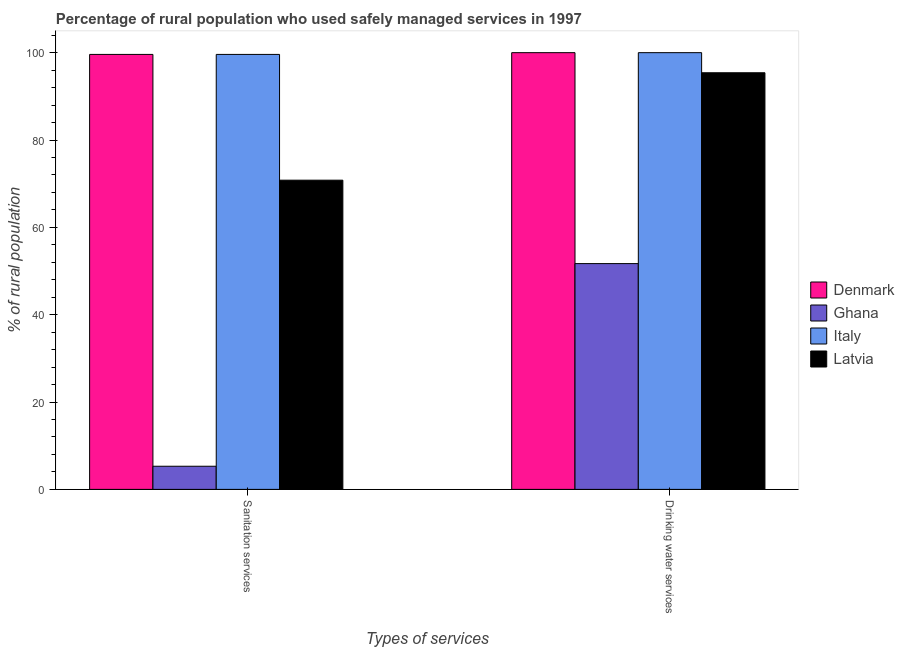How many different coloured bars are there?
Keep it short and to the point. 4. How many bars are there on the 1st tick from the left?
Keep it short and to the point. 4. How many bars are there on the 1st tick from the right?
Make the answer very short. 4. What is the label of the 2nd group of bars from the left?
Offer a very short reply. Drinking water services. What is the percentage of rural population who used sanitation services in Latvia?
Your response must be concise. 70.8. Across all countries, what is the maximum percentage of rural population who used sanitation services?
Your answer should be very brief. 99.6. Across all countries, what is the minimum percentage of rural population who used drinking water services?
Offer a very short reply. 51.7. In which country was the percentage of rural population who used sanitation services maximum?
Offer a very short reply. Denmark. What is the total percentage of rural population who used sanitation services in the graph?
Make the answer very short. 275.3. What is the difference between the percentage of rural population who used sanitation services in Denmark and that in Latvia?
Your answer should be very brief. 28.8. What is the difference between the percentage of rural population who used sanitation services in Italy and the percentage of rural population who used drinking water services in Ghana?
Keep it short and to the point. 47.9. What is the average percentage of rural population who used drinking water services per country?
Offer a terse response. 86.78. What is the difference between the percentage of rural population who used sanitation services and percentage of rural population who used drinking water services in Denmark?
Give a very brief answer. -0.4. In how many countries, is the percentage of rural population who used drinking water services greater than 84 %?
Offer a very short reply. 3. What is the ratio of the percentage of rural population who used sanitation services in Ghana to that in Denmark?
Offer a terse response. 0.05. Is the percentage of rural population who used drinking water services in Ghana less than that in Denmark?
Provide a short and direct response. Yes. What does the 3rd bar from the left in Sanitation services represents?
Your response must be concise. Italy. How many bars are there?
Provide a succinct answer. 8. Are all the bars in the graph horizontal?
Give a very brief answer. No. How many countries are there in the graph?
Keep it short and to the point. 4. Are the values on the major ticks of Y-axis written in scientific E-notation?
Your answer should be compact. No. Does the graph contain grids?
Offer a very short reply. No. Where does the legend appear in the graph?
Provide a succinct answer. Center right. What is the title of the graph?
Your answer should be compact. Percentage of rural population who used safely managed services in 1997. Does "Cote d'Ivoire" appear as one of the legend labels in the graph?
Your answer should be compact. No. What is the label or title of the X-axis?
Offer a very short reply. Types of services. What is the label or title of the Y-axis?
Offer a very short reply. % of rural population. What is the % of rural population of Denmark in Sanitation services?
Make the answer very short. 99.6. What is the % of rural population in Italy in Sanitation services?
Provide a short and direct response. 99.6. What is the % of rural population in Latvia in Sanitation services?
Your answer should be very brief. 70.8. What is the % of rural population of Ghana in Drinking water services?
Provide a short and direct response. 51.7. What is the % of rural population of Latvia in Drinking water services?
Your response must be concise. 95.4. Across all Types of services, what is the maximum % of rural population in Denmark?
Ensure brevity in your answer.  100. Across all Types of services, what is the maximum % of rural population of Ghana?
Offer a terse response. 51.7. Across all Types of services, what is the maximum % of rural population of Italy?
Ensure brevity in your answer.  100. Across all Types of services, what is the maximum % of rural population in Latvia?
Your answer should be compact. 95.4. Across all Types of services, what is the minimum % of rural population in Denmark?
Keep it short and to the point. 99.6. Across all Types of services, what is the minimum % of rural population of Italy?
Keep it short and to the point. 99.6. Across all Types of services, what is the minimum % of rural population in Latvia?
Your answer should be compact. 70.8. What is the total % of rural population of Denmark in the graph?
Offer a terse response. 199.6. What is the total % of rural population in Italy in the graph?
Offer a terse response. 199.6. What is the total % of rural population in Latvia in the graph?
Ensure brevity in your answer.  166.2. What is the difference between the % of rural population of Ghana in Sanitation services and that in Drinking water services?
Keep it short and to the point. -46.4. What is the difference between the % of rural population of Italy in Sanitation services and that in Drinking water services?
Give a very brief answer. -0.4. What is the difference between the % of rural population in Latvia in Sanitation services and that in Drinking water services?
Your response must be concise. -24.6. What is the difference between the % of rural population in Denmark in Sanitation services and the % of rural population in Ghana in Drinking water services?
Your answer should be compact. 47.9. What is the difference between the % of rural population in Denmark in Sanitation services and the % of rural population in Latvia in Drinking water services?
Offer a very short reply. 4.2. What is the difference between the % of rural population of Ghana in Sanitation services and the % of rural population of Italy in Drinking water services?
Your answer should be very brief. -94.7. What is the difference between the % of rural population in Ghana in Sanitation services and the % of rural population in Latvia in Drinking water services?
Give a very brief answer. -90.1. What is the difference between the % of rural population in Italy in Sanitation services and the % of rural population in Latvia in Drinking water services?
Offer a terse response. 4.2. What is the average % of rural population of Denmark per Types of services?
Keep it short and to the point. 99.8. What is the average % of rural population of Ghana per Types of services?
Your answer should be compact. 28.5. What is the average % of rural population of Italy per Types of services?
Ensure brevity in your answer.  99.8. What is the average % of rural population in Latvia per Types of services?
Ensure brevity in your answer.  83.1. What is the difference between the % of rural population of Denmark and % of rural population of Ghana in Sanitation services?
Keep it short and to the point. 94.3. What is the difference between the % of rural population in Denmark and % of rural population in Italy in Sanitation services?
Offer a very short reply. 0. What is the difference between the % of rural population in Denmark and % of rural population in Latvia in Sanitation services?
Provide a short and direct response. 28.8. What is the difference between the % of rural population in Ghana and % of rural population in Italy in Sanitation services?
Your answer should be very brief. -94.3. What is the difference between the % of rural population in Ghana and % of rural population in Latvia in Sanitation services?
Offer a very short reply. -65.5. What is the difference between the % of rural population in Italy and % of rural population in Latvia in Sanitation services?
Give a very brief answer. 28.8. What is the difference between the % of rural population in Denmark and % of rural population in Ghana in Drinking water services?
Give a very brief answer. 48.3. What is the difference between the % of rural population in Ghana and % of rural population in Italy in Drinking water services?
Offer a terse response. -48.3. What is the difference between the % of rural population of Ghana and % of rural population of Latvia in Drinking water services?
Give a very brief answer. -43.7. What is the difference between the % of rural population in Italy and % of rural population in Latvia in Drinking water services?
Give a very brief answer. 4.6. What is the ratio of the % of rural population of Ghana in Sanitation services to that in Drinking water services?
Your answer should be very brief. 0.1. What is the ratio of the % of rural population of Italy in Sanitation services to that in Drinking water services?
Provide a succinct answer. 1. What is the ratio of the % of rural population in Latvia in Sanitation services to that in Drinking water services?
Provide a succinct answer. 0.74. What is the difference between the highest and the second highest % of rural population in Ghana?
Keep it short and to the point. 46.4. What is the difference between the highest and the second highest % of rural population in Italy?
Your answer should be compact. 0.4. What is the difference between the highest and the second highest % of rural population of Latvia?
Keep it short and to the point. 24.6. What is the difference between the highest and the lowest % of rural population of Denmark?
Give a very brief answer. 0.4. What is the difference between the highest and the lowest % of rural population in Ghana?
Your answer should be compact. 46.4. What is the difference between the highest and the lowest % of rural population of Latvia?
Offer a terse response. 24.6. 